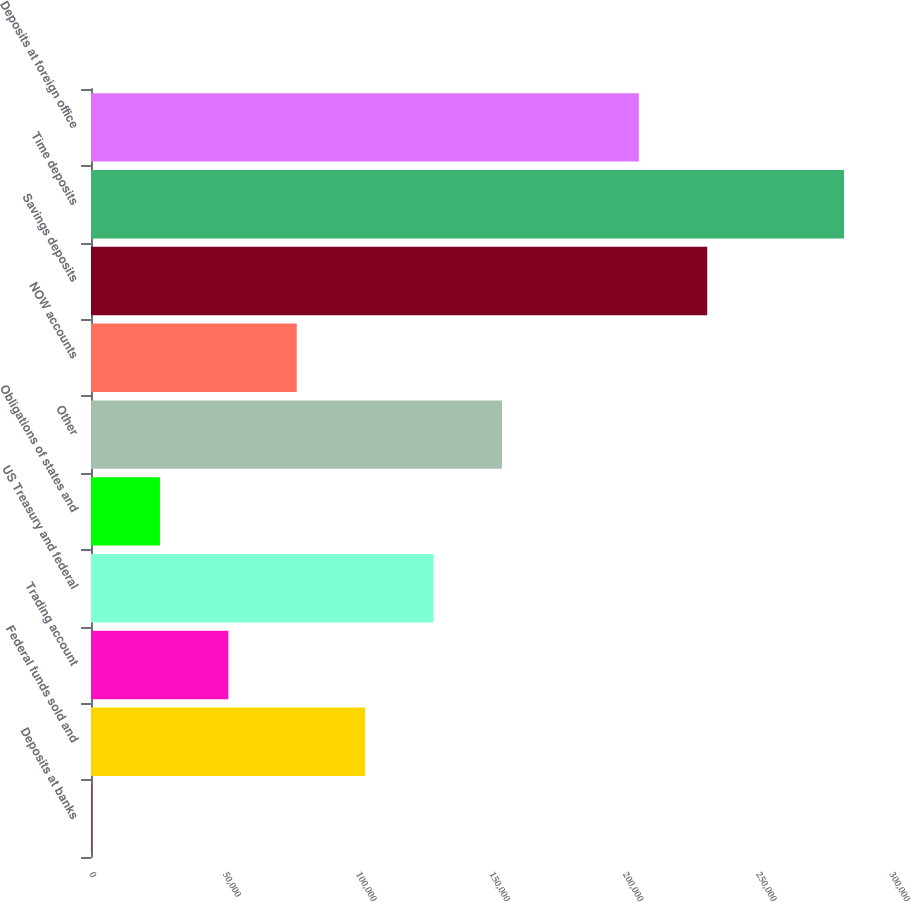<chart> <loc_0><loc_0><loc_500><loc_500><bar_chart><fcel>Deposits at banks<fcel>Federal funds sold and<fcel>Trading account<fcel>US Treasury and federal<fcel>Obligations of states and<fcel>Other<fcel>NOW accounts<fcel>Savings deposits<fcel>Time deposits<fcel>Deposits at foreign office<nl><fcel>203<fcel>102815<fcel>51508.8<fcel>128468<fcel>25855.9<fcel>154120<fcel>77161.7<fcel>231079<fcel>282385<fcel>205426<nl></chart> 